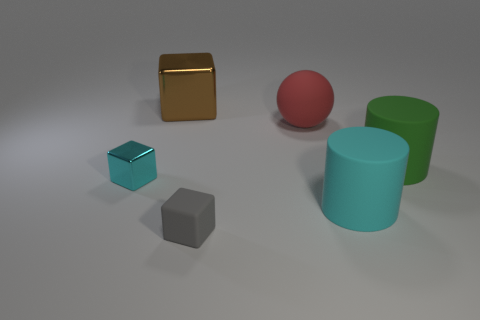What size is the cyan thing that is the same material as the big brown object?
Make the answer very short. Small. Is the gray object the same size as the green rubber thing?
Ensure brevity in your answer.  No. What number of things are either shiny blocks that are behind the big red object or cyan metallic things?
Give a very brief answer. 2. How big is the object behind the large red matte object?
Give a very brief answer. Large. There is a brown metallic object; does it have the same size as the cyan object that is to the right of the large brown metallic block?
Ensure brevity in your answer.  Yes. There is a large rubber thing that is in front of the large rubber cylinder that is behind the cyan matte thing; what is its color?
Make the answer very short. Cyan. How many other objects are there of the same color as the large metal object?
Ensure brevity in your answer.  0. What size is the rubber block?
Keep it short and to the point. Small. Is the number of objects that are to the left of the large brown block greater than the number of tiny metal cubes behind the red thing?
Your answer should be very brief. Yes. There is a shiny thing that is in front of the large red ball; what number of blocks are right of it?
Offer a terse response. 2. 